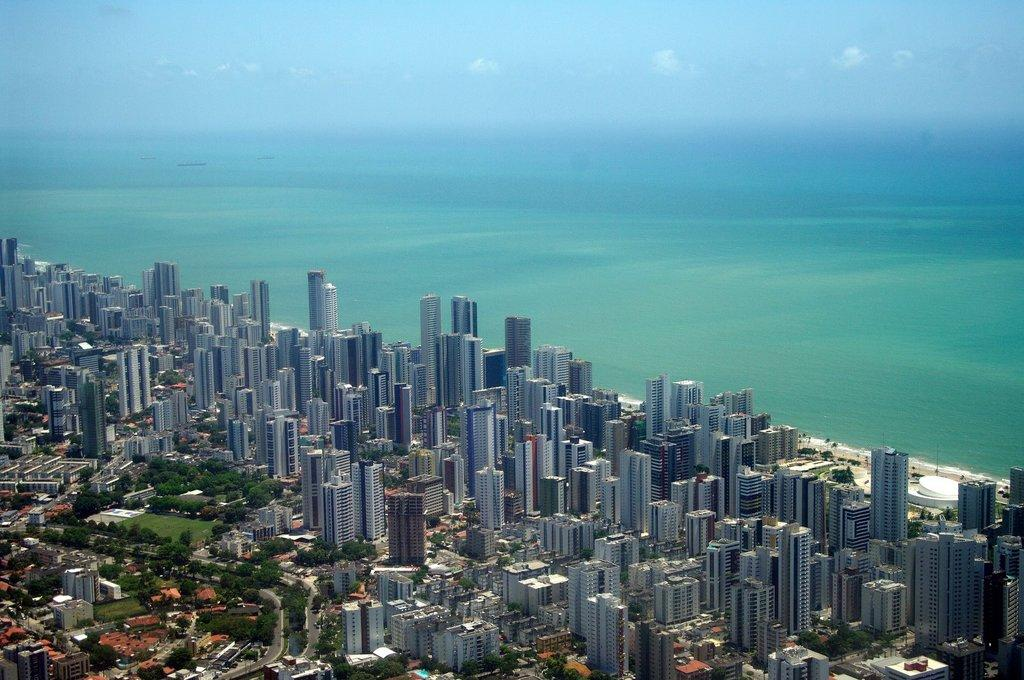What type of structures are present in the image? There is a group of buildings in the image. What type of vegetation can be seen in the image? There are trees and grass visible in the image. What is located behind the buildings? There is water behind the buildings. What is visible at the top of the image? The sky is visible at the top of the image. Can you describe the example of hair on the trees in the image? There is no mention of hair on the trees in the image; the trees are described as having leaves or branches. How many ducks are swimming in the water behind the buildings? There are no ducks present in the image; it only shows water behind the buildings. 